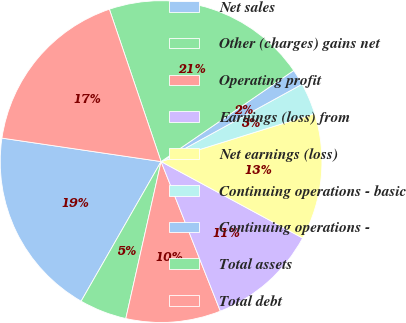<chart> <loc_0><loc_0><loc_500><loc_500><pie_chart><fcel>Net sales<fcel>Other (charges) gains net<fcel>Operating profit<fcel>Earnings (loss) from<fcel>Net earnings (loss)<fcel>Continuing operations - basic<fcel>Continuing operations -<fcel>Total assets<fcel>Total debt<nl><fcel>19.05%<fcel>4.76%<fcel>9.52%<fcel>11.11%<fcel>12.7%<fcel>3.17%<fcel>1.59%<fcel>20.63%<fcel>17.46%<nl></chart> 